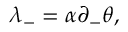<formula> <loc_0><loc_0><loc_500><loc_500>\lambda _ { - } = \alpha \partial _ { - } \theta ,</formula> 